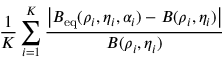Convert formula to latex. <formula><loc_0><loc_0><loc_500><loc_500>\frac { 1 } { K } \sum _ { i = 1 } ^ { K } \frac { \left | B _ { e q } ( \rho _ { i } , \eta _ { i } , \alpha _ { i } ) - B ( \rho _ { i } , \eta _ { i } ) \right | } { B ( \rho _ { i } , \eta _ { i } ) }</formula> 